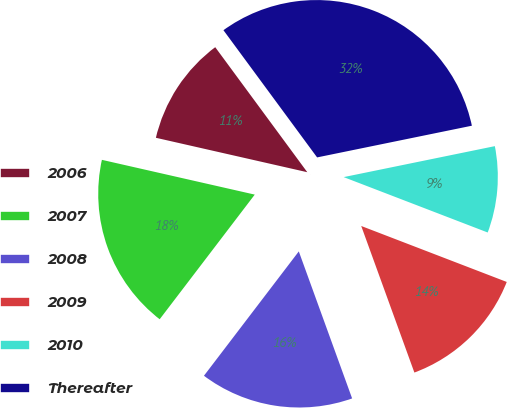Convert chart to OTSL. <chart><loc_0><loc_0><loc_500><loc_500><pie_chart><fcel>2006<fcel>2007<fcel>2008<fcel>2009<fcel>2010<fcel>Thereafter<nl><fcel>11.34%<fcel>18.19%<fcel>15.91%<fcel>13.62%<fcel>9.06%<fcel>31.89%<nl></chart> 